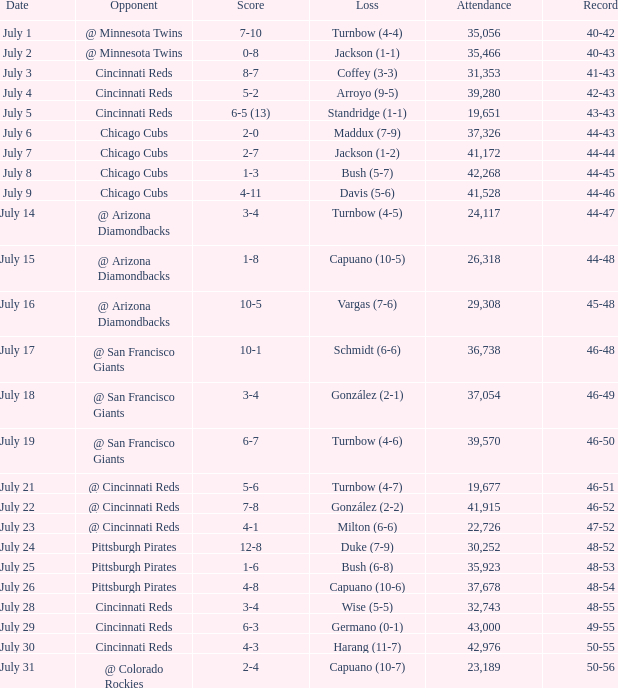What was the record at the game that had a score of 7-10? 40-42. 